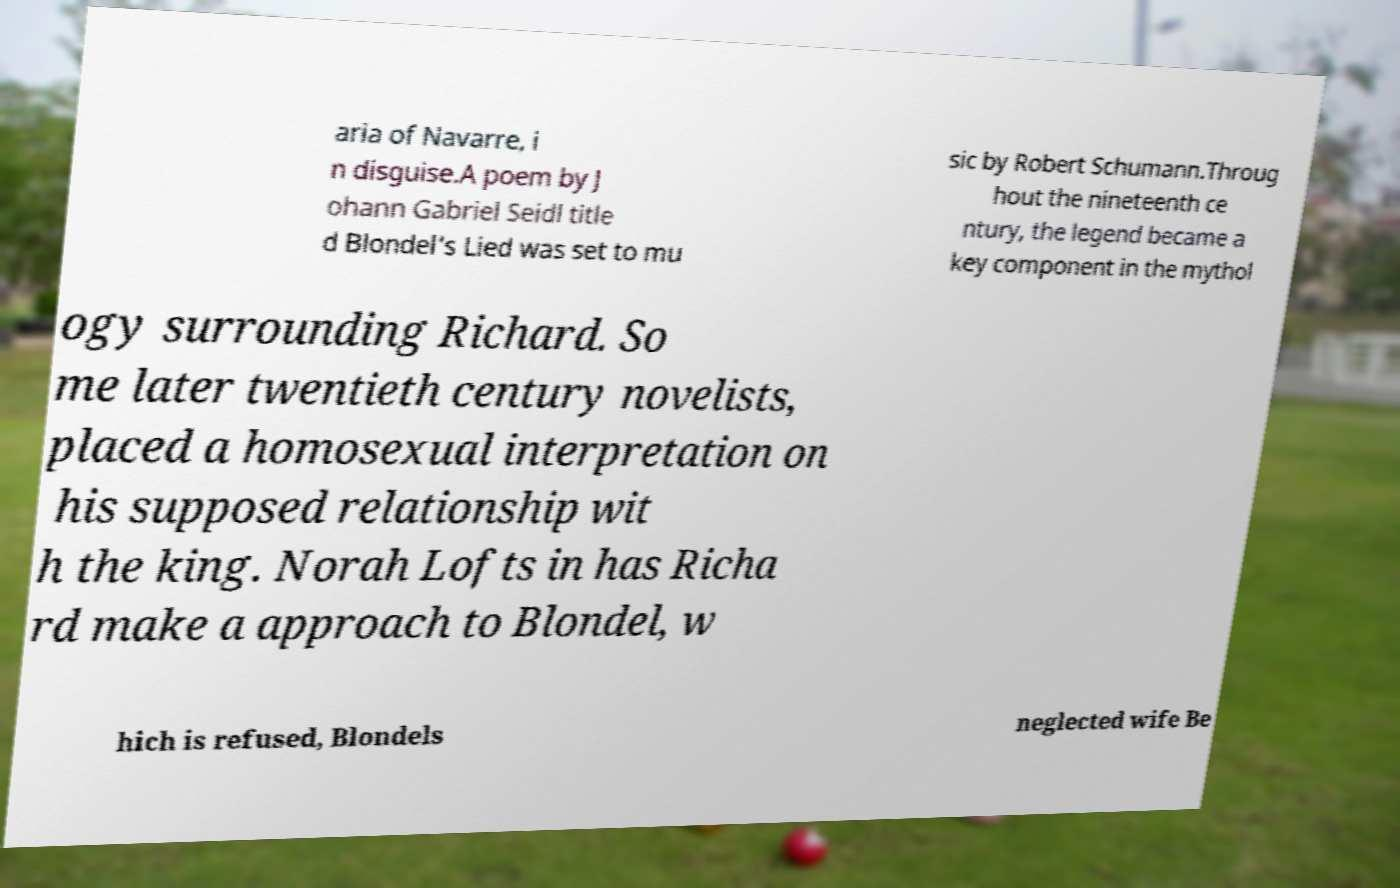There's text embedded in this image that I need extracted. Can you transcribe it verbatim? aria of Navarre, i n disguise.A poem by J ohann Gabriel Seidl title d Blondel's Lied was set to mu sic by Robert Schumann.Throug hout the nineteenth ce ntury, the legend became a key component in the mythol ogy surrounding Richard. So me later twentieth century novelists, placed a homosexual interpretation on his supposed relationship wit h the king. Norah Lofts in has Richa rd make a approach to Blondel, w hich is refused, Blondels neglected wife Be 